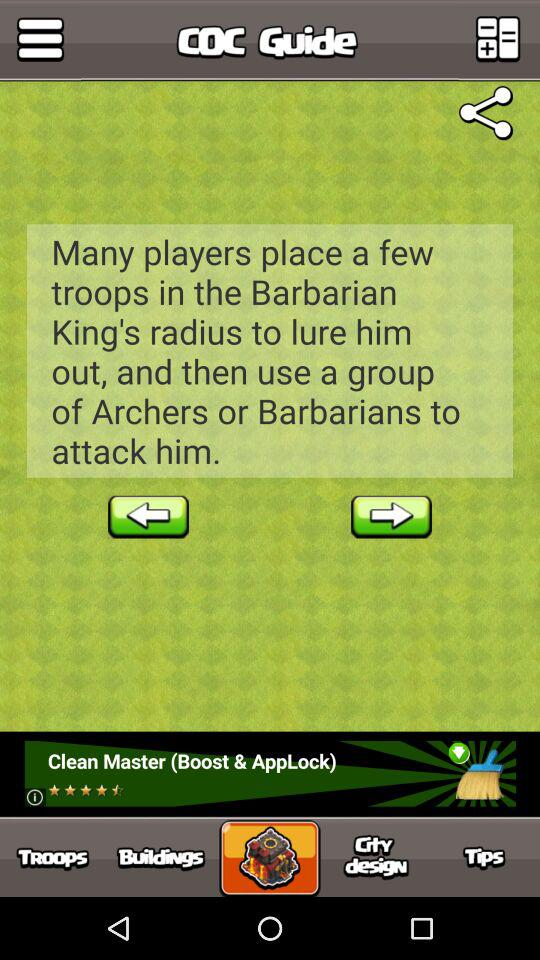What is the application name? The application name is "COC Guide". 